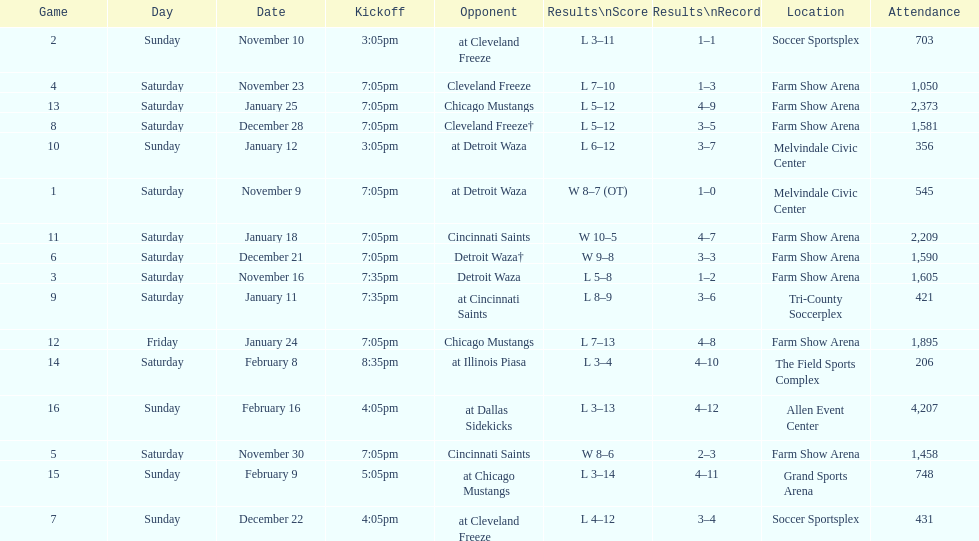Which opponent is listed after cleveland freeze in the table? Detroit Waza. 